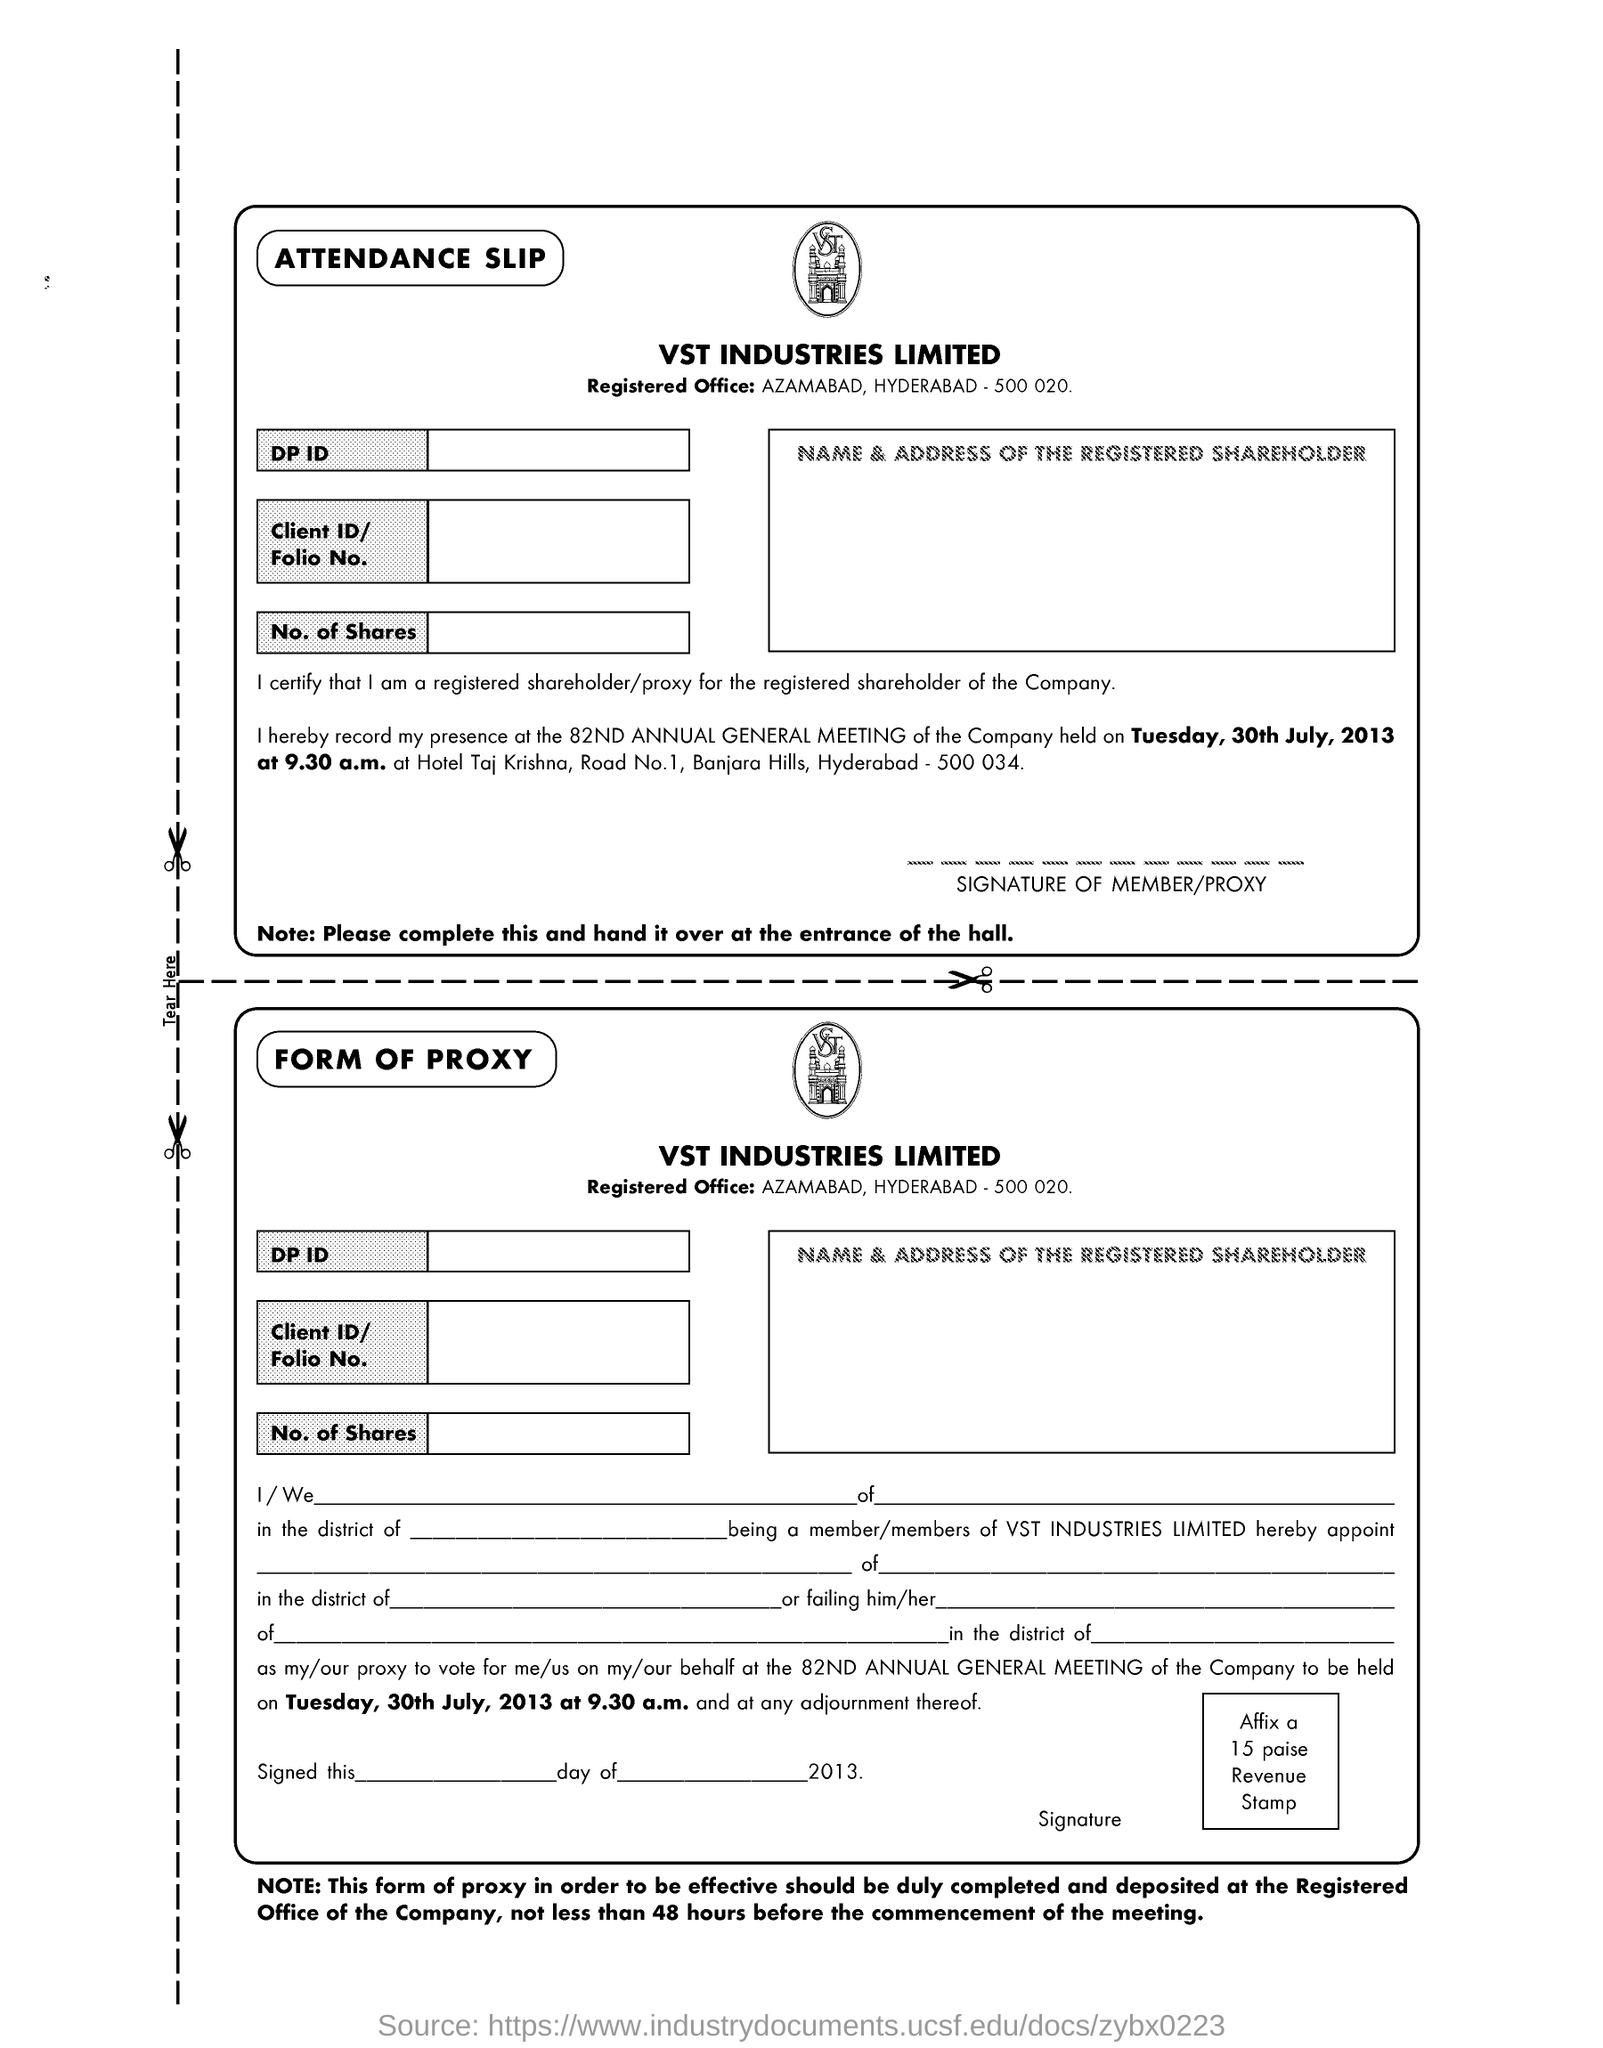Specify some key components in this picture. On Tuesday, July 30th, 2013, the 82nd Annual General Meeting was held. It is imperative to hand over the attendance slip at the entrance of the hall. The registered office of the company is located in Azamabad, Hyderabad, as indicated in the given address: "What is the location of the Registered Office ? Azamabad, Hyderabad - 500 020.. The document mentions the industry VST. 